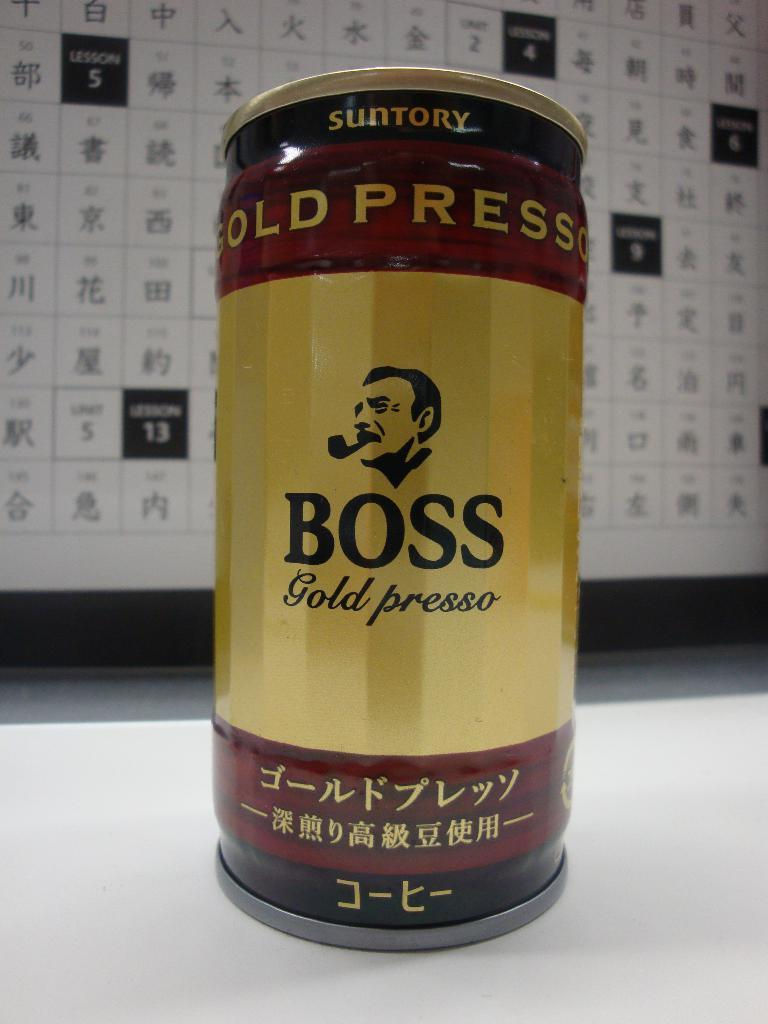<image>
Describe the image concisely. A gold, red and black can of Boss has Asian symbols on the front. 